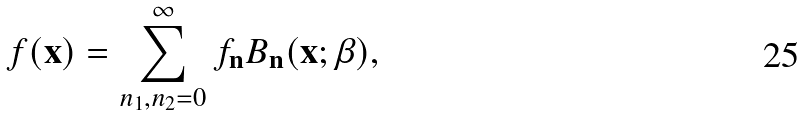Convert formula to latex. <formula><loc_0><loc_0><loc_500><loc_500>f ( { \mathbf x } ) = \sum _ { n _ { 1 } , n _ { 2 } = 0 } ^ { \infty } f _ { \mathbf n } B _ { \mathbf n } ( { \mathbf x } ; \beta ) ,</formula> 